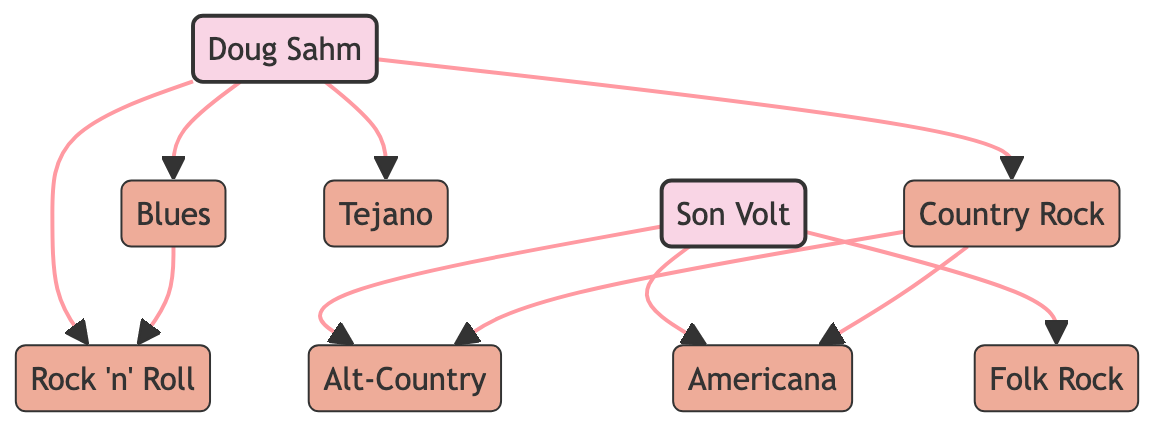What's the number of nodes in the diagram? The diagram contains eight unique nodes: Doug Sahm, Son Volt, Country Rock, Tejano, Blues, Folk Rock, Americana, and Alt-Country.
Answer: 8 Which genre is directly connected to Doug Sahm? The edges from Doug Sahm lead to Tejano, Blues, Country Rock, and Rock 'n' Roll. Therefore, any of these four genres are directly connected to him.
Answer: Tejano, Blues, Country Rock, Rock 'n' Roll What is the relationship between Son Volt and Americana? The edge indicates a direct connection from Son Volt to Americana, meaning that Son Volt is associated with this genre.
Answer: Son Volt is associated with Americana Which genre leads to Alt-Country? There is a direct edge from Country Rock to Alt-Country, indicating that Country Rock influences or branches into Alt-Country.
Answer: Country Rock What are all the genres that Doug Sahm is linked to directly? Doug Sahm has edges leading to Tejano, Blues, Country Rock, and Rock 'n' Roll, so these are the genres linked directly to him.
Answer: Tejano, Blues, Country Rock, Rock 'n' Roll How many genres does Son Volt connect to and which ones are they? Son Volt directly connects to three genres: Alt-Country, Americana, and Folk Rock, as shown by the edges leading from Son Volt.
Answer: 3: Alt-Country, Americana, Folk Rock Which genre connects both Blues and Rock 'n' Roll? The edge leads from Blues to Rock 'n' Roll, showing a direct connection between these two genres.
Answer: Blues How many edges are present in the diagram? The diagram includes a total of nine edges connecting the different nodes, representing the relationships among the artists and genres.
Answer: 9 Which genre serves as a path to both Alt-Country and Americana? The diagram shows that Country Rock leads to both Alt-Country and Americana, indicating it is a connective bridge for these genres.
Answer: Country Rock 